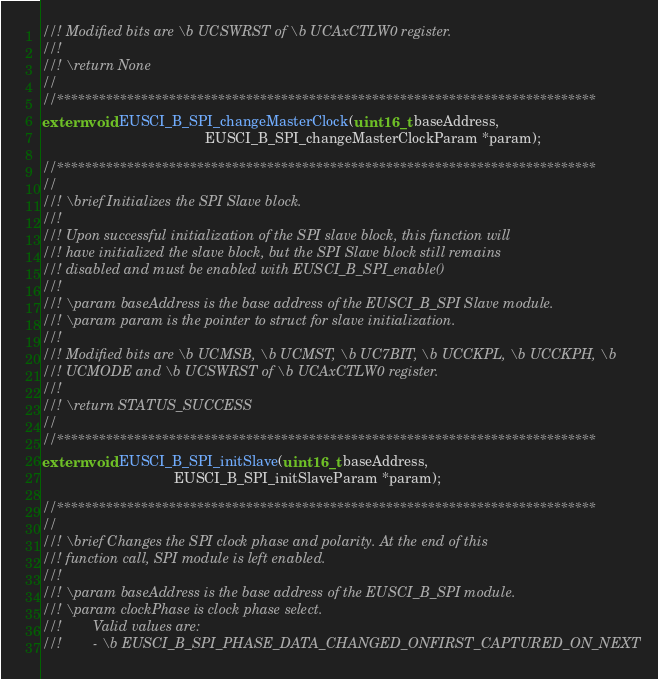Convert code to text. <code><loc_0><loc_0><loc_500><loc_500><_C_>//! Modified bits are \b UCSWRST of \b UCAxCTLW0 register.
//!
//! \return None
//
//*****************************************************************************
extern void EUSCI_B_SPI_changeMasterClock(uint16_t baseAddress,
                                          EUSCI_B_SPI_changeMasterClockParam *param);

//*****************************************************************************
//
//! \brief Initializes the SPI Slave block.
//!
//! Upon successful initialization of the SPI slave block, this function will
//! have initialized the slave block, but the SPI Slave block still remains
//! disabled and must be enabled with EUSCI_B_SPI_enable()
//!
//! \param baseAddress is the base address of the EUSCI_B_SPI Slave module.
//! \param param is the pointer to struct for slave initialization.
//!
//! Modified bits are \b UCMSB, \b UCMST, \b UC7BIT, \b UCCKPL, \b UCCKPH, \b
//! UCMODE and \b UCSWRST of \b UCAxCTLW0 register.
//!
//! \return STATUS_SUCCESS
//
//*****************************************************************************
extern void EUSCI_B_SPI_initSlave(uint16_t baseAddress,
                                  EUSCI_B_SPI_initSlaveParam *param);

//*****************************************************************************
//
//! \brief Changes the SPI clock phase and polarity. At the end of this
//! function call, SPI module is left enabled.
//!
//! \param baseAddress is the base address of the EUSCI_B_SPI module.
//! \param clockPhase is clock phase select.
//!        Valid values are:
//!        - \b EUSCI_B_SPI_PHASE_DATA_CHANGED_ONFIRST_CAPTURED_ON_NEXT</code> 